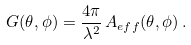<formula> <loc_0><loc_0><loc_500><loc_500>G ( \theta , \phi ) = \frac { 4 \pi } { \lambda ^ { 2 } } \, A _ { e f f } ( \theta , \phi ) \, .</formula> 